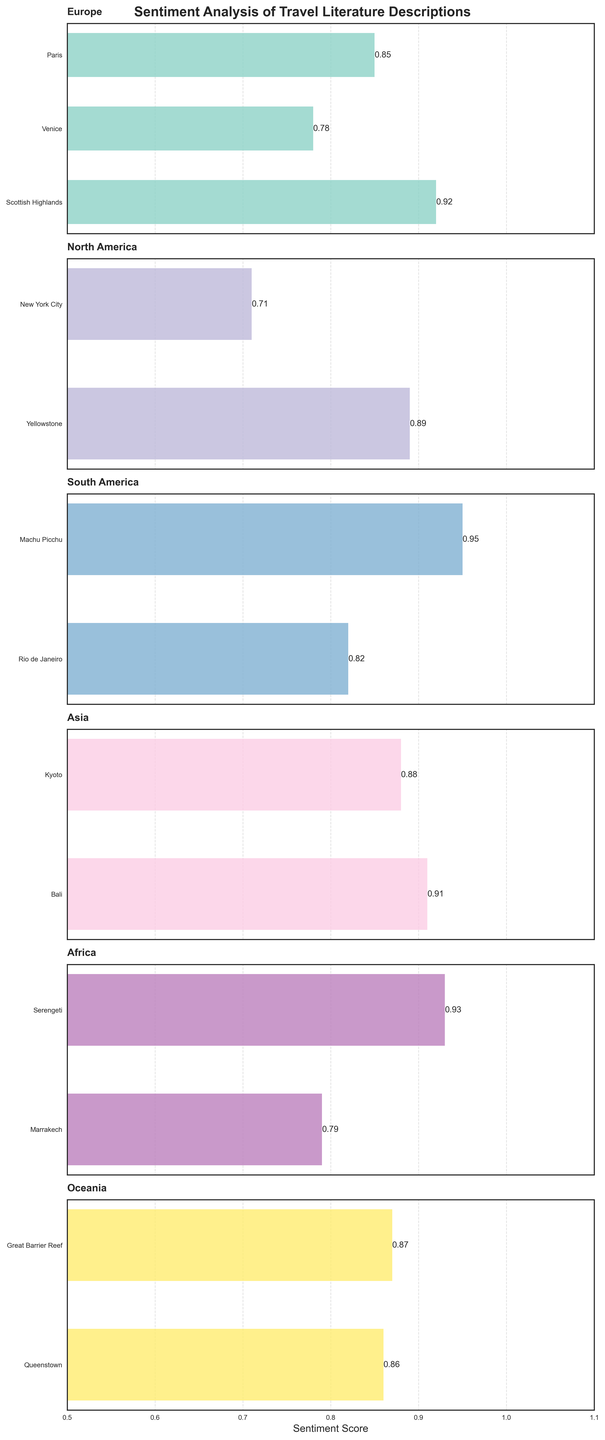What's the title of the figure? The title is found at the top-center of the figure and summarizes its content.
Answer: Sentiment Analysis of Travel Literature Descriptions How many continents are represented in the figure? By looking at the number of subplots, each representing a different continent, you can count the total number.
Answer: 6 Which location has the highest sentiment score in Europe? By examining the bar heights and their labels within the Europe subplot, you can identify the bar with the highest sentiment score.
Answer: Scottish Highlands What is the average sentiment score for locations in North America? Add the sentiment scores for New York City and Yellowstone, then divide by the number of locations (2). Calculation: (0.71 + 0.89) / 2 = 1.60 / 2
Answer: 0.80 Compare the sentiment scores of Rio de Janeiro and Marrakech. Which one is higher? Locate the sentiment scores for Rio de Janeiro in South America and Marrakech in Africa, then compare them directly.
Answer: Rio de Janeiro What is the sentiment score difference between Serengeti and Marrakech? Find the sentiment scores for both Serengeti and Marrakech within the Africa subplot: Serengeti (0.93) and Marrakech (0.79). Subtract the smaller from the larger one: 0.93 - 0.79 = 0.14
Answer: 0.14 Which location has the lowest sentiment score in the entire dataset? Review each continent's subplot to find the smallest sentiment score. New York City (0.71) is the lowest in North America compared to others.
Answer: New York City What is the combined sentiment score of all locations in South America? Sum the sentiment scores for Machu Picchu (0.95) and Rio de Janeiro (0.82) to find the total. 0.95 + 0.82 = 1.77
Answer: 1.77 Is the sentiment score for the Great Barrier Reef above or below 0.90? Refer to the Oceania subplot, examining the bar height for the Great Barrier Reef and its exact score (0.87).
Answer: Below 